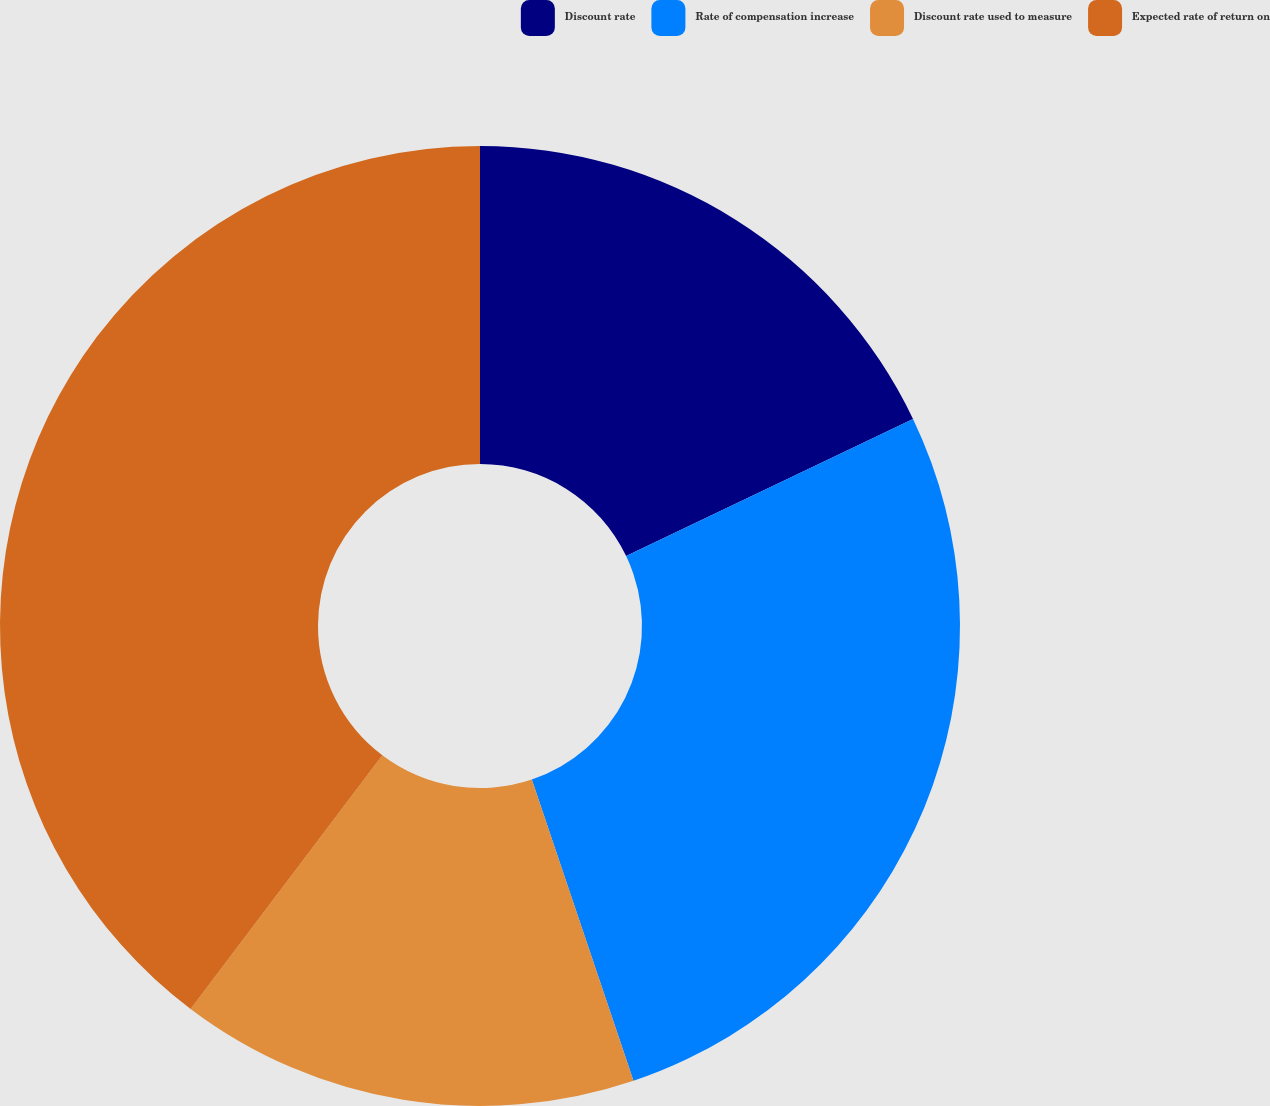<chart> <loc_0><loc_0><loc_500><loc_500><pie_chart><fcel>Discount rate<fcel>Rate of compensation increase<fcel>Discount rate used to measure<fcel>Expected rate of return on<nl><fcel>17.9%<fcel>26.92%<fcel>15.48%<fcel>39.7%<nl></chart> 